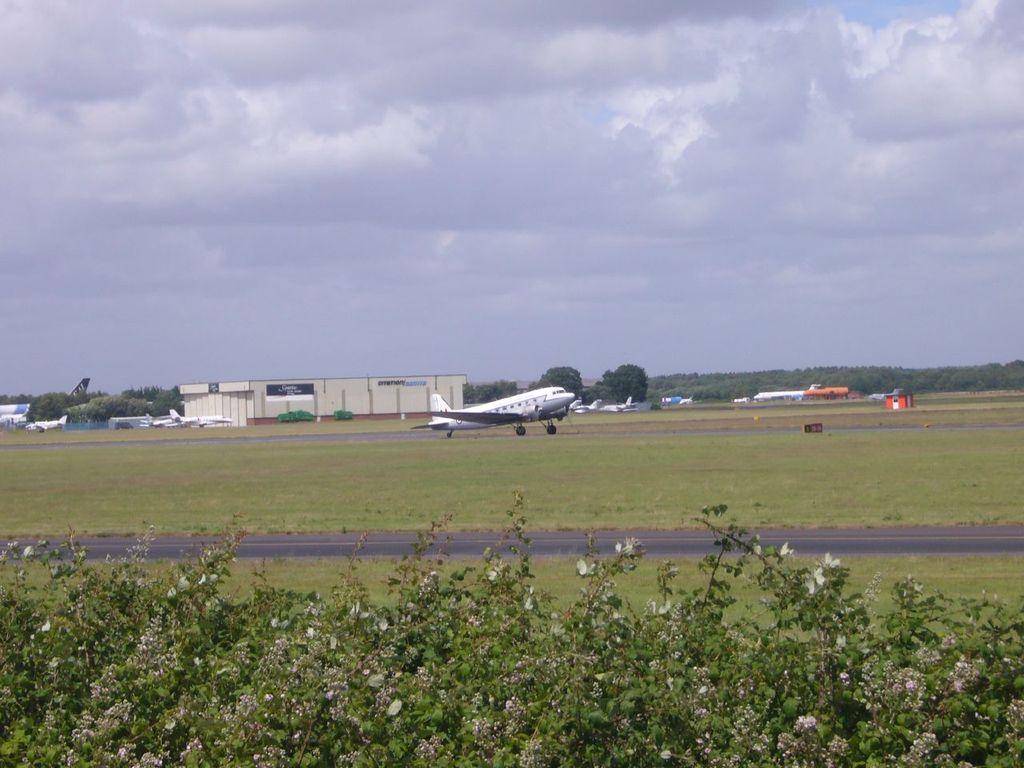Please provide a concise description of this image. In this image there are plants at the bottom. In the middle there is an airplane on the runway. In the background there are buildings. At the top there is the sky. There are few airplanes on the ground. 